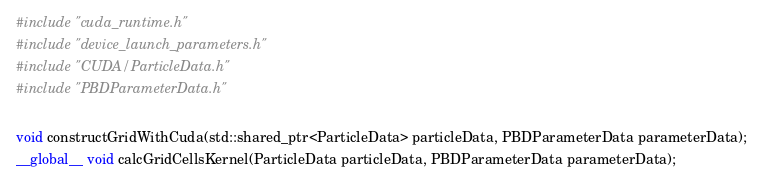<code> <loc_0><loc_0><loc_500><loc_500><_Cuda_>#include "cuda_runtime.h"
#include "device_launch_parameters.h"
#include "CUDA/ParticleData.h"
#include "PBDParameterData.h"

void constructGridWithCuda(std::shared_ptr<ParticleData> particleData, PBDParameterData parameterData);
__global__ void calcGridCellsKernel(ParticleData particleData, PBDParameterData parameterData);</code> 